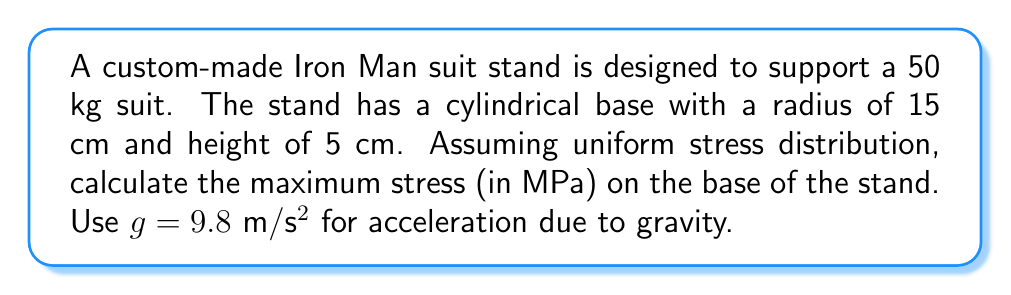Teach me how to tackle this problem. To calculate the maximum stress on the base of the Iron Man suit stand, we'll follow these steps:

1. Calculate the weight of the suit:
   $F = mg$
   $F = 50 \text{ kg} \times 9.8 \text{ m/s²} = 490 \text{ N}$

2. Calculate the area of the base:
   $A = \pi r^2$
   $A = \pi \times (0.15 \text{ m})^2 = 0.0707 \text{ m²}$

3. Calculate the stress using the formula:
   $$\sigma = \frac{F}{A}$$
   Where:
   $\sigma$ is the stress
   $F$ is the force (weight of the suit)
   $A$ is the area of the base

4. Substitute the values:
   $$\sigma = \frac{490 \text{ N}}{0.0707 \text{ m²}} = 6,930.69 \text{ Pa}$$

5. Convert Pa to MPa:
   $$6,930.69 \text{ Pa} = 0.00693069 \text{ MPa}$$

6. Round to 4 decimal places:
   $$0.0069 \text{ MPa}$$
Answer: 0.0069 MPa 